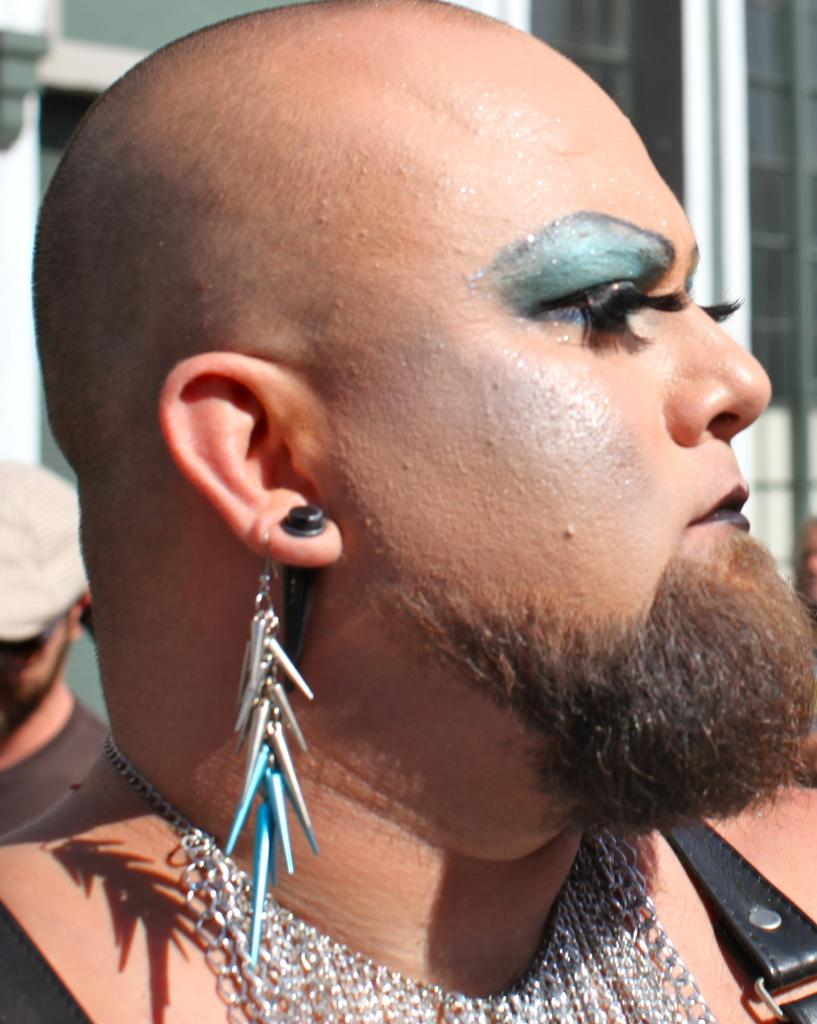What is the main subject in the foreground of the image? There is a person in the foreground of the image. What accessories is the person wearing? The person is wearing earrings and a necklace. What can be seen in the background of the image? There are other persons and buildings in the background of the image. What type of liquid is being poured into the loaf in the image? There is no loaf or liquid present in the image. 